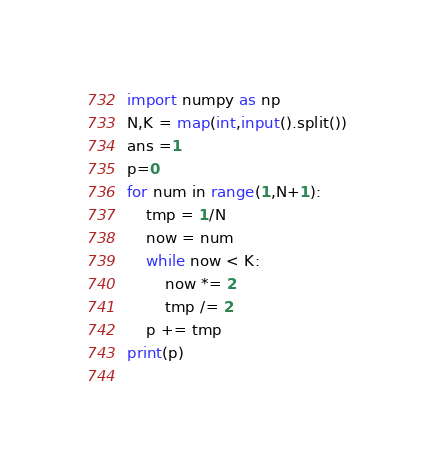Convert code to text. <code><loc_0><loc_0><loc_500><loc_500><_Python_>import numpy as np
N,K = map(int,input().split())
ans =1
p=0
for num in range(1,N+1):
    tmp = 1/N
    now = num
    while now < K:
        now *= 2
        tmp /= 2
    p += tmp
print(p)
    </code> 